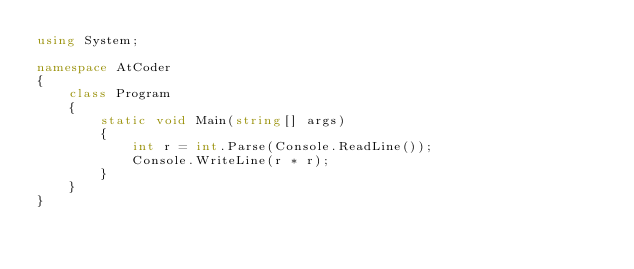Convert code to text. <code><loc_0><loc_0><loc_500><loc_500><_C#_>using System;

namespace AtCoder
{
    class Program
    {
        static void Main(string[] args)
        {
            int r = int.Parse(Console.ReadLine());
            Console.WriteLine(r * r);
        }
    }
}
</code> 